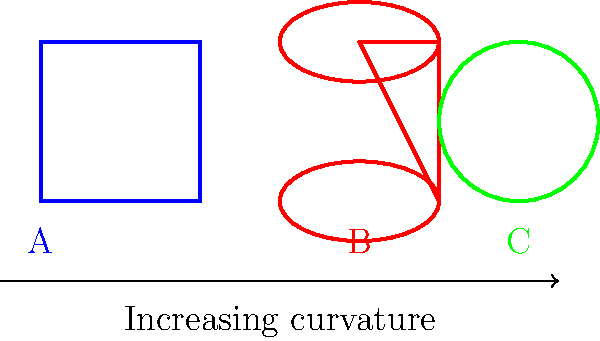The image shows three gift-wrapping patterns (A, B, and C) with increasing curvature. Which pattern would be most suitable for wrapping a spherical object like a ball? To answer this question, we need to consider the relationship between the shape of an object and the most appropriate wrapping pattern:

1. Pattern A (blue) shows straight lines and sharp corners, indicating a box-like shape with flat surfaces.
2. Pattern B (red) displays curved sides but flat top and bottom, suggesting a cylindrical object.
3. Pattern C (green) exhibits a uniformly curved surface, implying a spherical shape.

The curvature of the wrapping pattern increases from A to C, as indicated by the arrow below the shapes.

For a spherical object like a ball:
- It has a uniform curvature in all directions.
- There are no flat surfaces or straight edges.
- The surface is continuously curved.

Among the given patterns, C (green) best matches these characteristics of a spherical object. It shows a uniformly curved surface without any flat areas or straight edges, making it the most suitable for wrapping a ball or any other spherical object.
Answer: C 